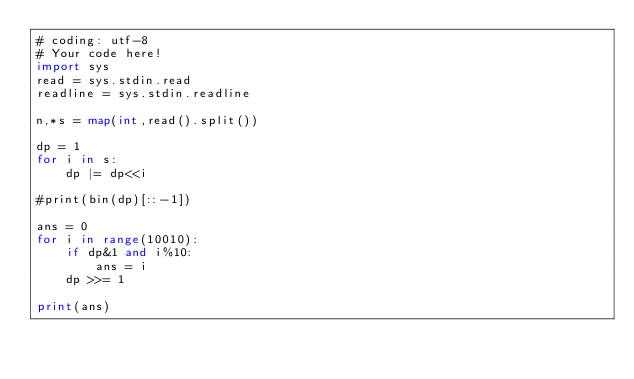<code> <loc_0><loc_0><loc_500><loc_500><_Python_># coding: utf-8
# Your code here!
import sys
read = sys.stdin.read
readline = sys.stdin.readline

n,*s = map(int,read().split())

dp = 1
for i in s:
    dp |= dp<<i

#print(bin(dp)[::-1])

ans = 0
for i in range(10010):
    if dp&1 and i%10:
        ans = i    
    dp >>= 1

print(ans)





</code> 